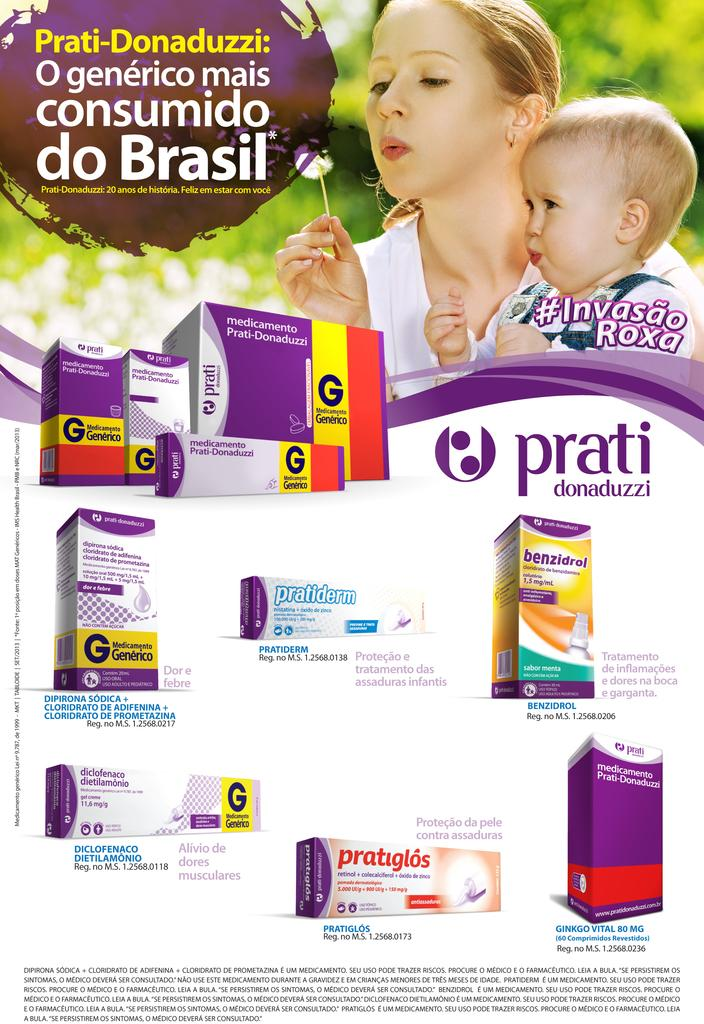Provide a one-sentence caption for the provided image. a prati advertisement has a mom and her child blowing bubbles. 